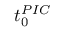<formula> <loc_0><loc_0><loc_500><loc_500>t _ { 0 } ^ { P I C }</formula> 